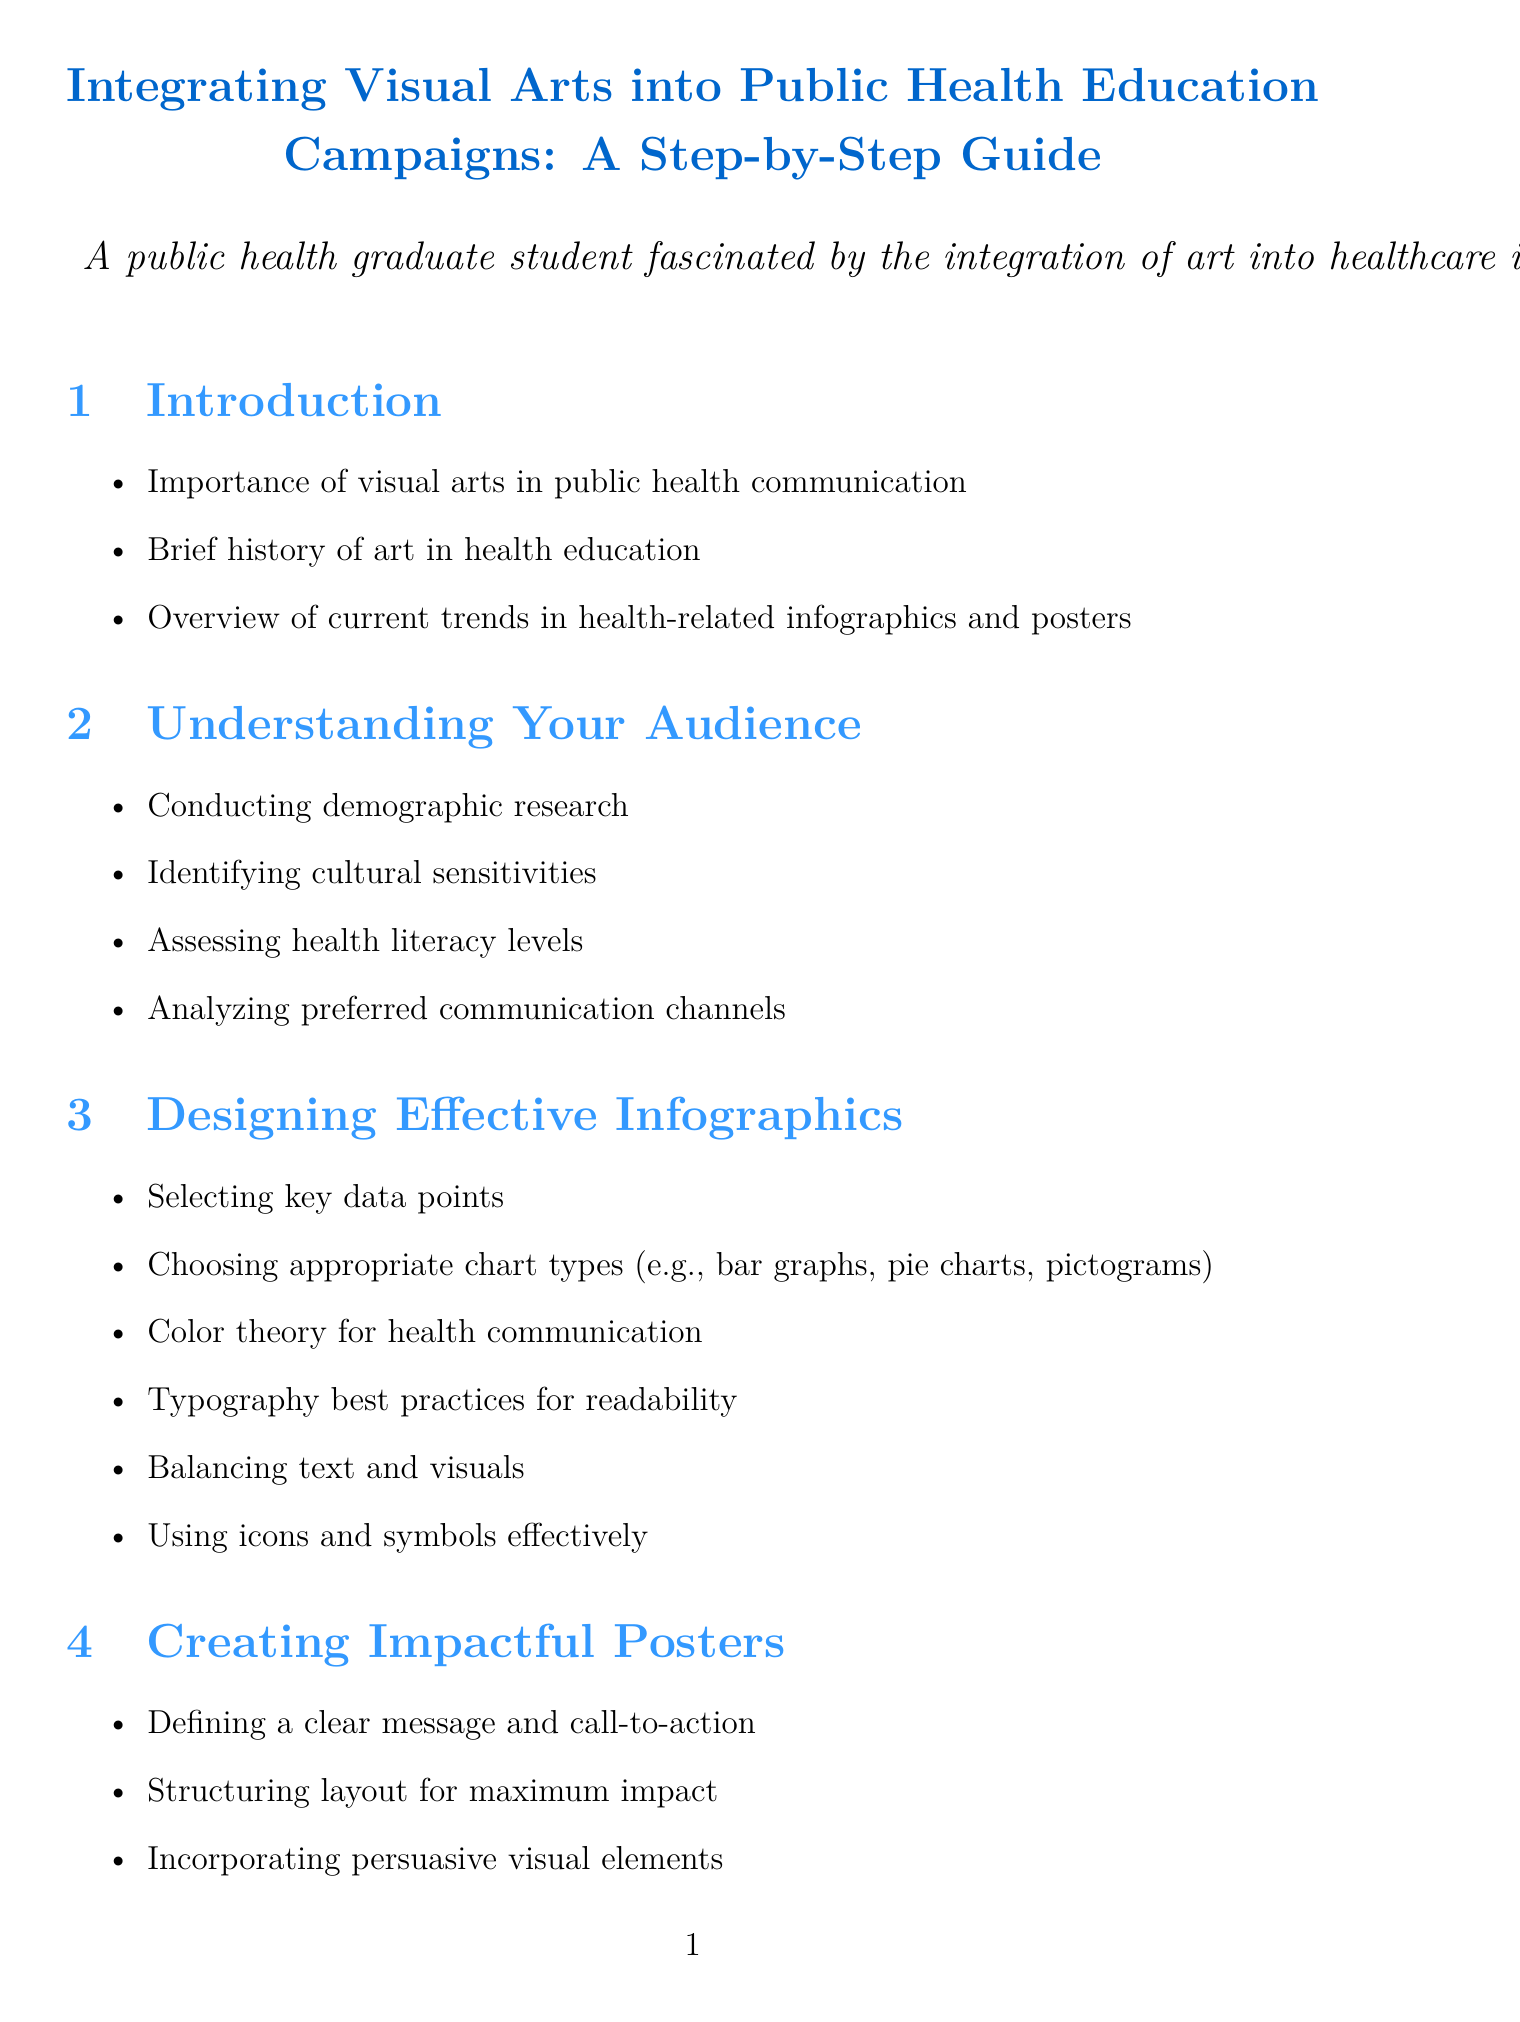What is the title of the manual? The title of the manual describes the focus on integrating visual arts into public health education, as presented in the document.
Answer: Integrating Visual Arts into Public Health Education Campaigns: A Step-by-Step Guide What section discusses the benefits of partnering with professional artists? This section specifically addresses the collaboration aspect between public health professionals and artists.
Answer: Collaboration with Artists How many case studies are mentioned in the manual? There are four specific case studies listed in the document, showcasing different public health campaigns.
Answer: 4 What color theory aspect is mentioned in designing infographics? The document covers color theory as a key principle in health communication for effective design.
Answer: Color theory for health communication What is one method for testing visual materials? This refers to the techniques used to evaluate the effectiveness of visual materials in public health campaigns.
Answer: Focus groups What should be defined in creating impactful posters? A clear message and call-to-action are crucial elements to include in poster design for better audience engagement.
Answer: Defining a clear message and call-to-action What is a tool mentioned for data visualization? This software is noted for assisting in the visual representation of data to convey health information.
Answer: Tableau What should be avoided in visual representations? This principle is important to ensure that populations are portrayed in a respectful and non-stigmatizing manner.
Answer: Avoiding stigmatization in visual representations What trend involves augmented reality? The document notes this innovative technology as part of the future trends in public health education.
Answer: Augmented reality in public health education 